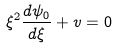Convert formula to latex. <formula><loc_0><loc_0><loc_500><loc_500>\xi ^ { 2 } \frac { d \psi _ { 0 } } { d \xi } + v = 0</formula> 